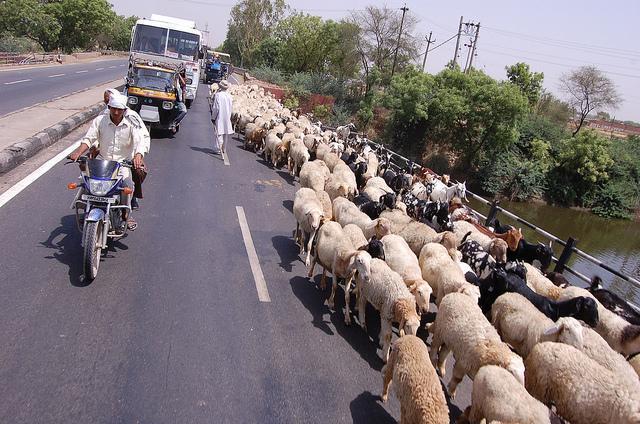What is clogging up the street?
Make your selection and explain in format: 'Answer: answer
Rationale: rationale.'
Options: Snow, mud, eggs, animals. Answer: animals.
Rationale: There are a bunch of sheep running down the street. 